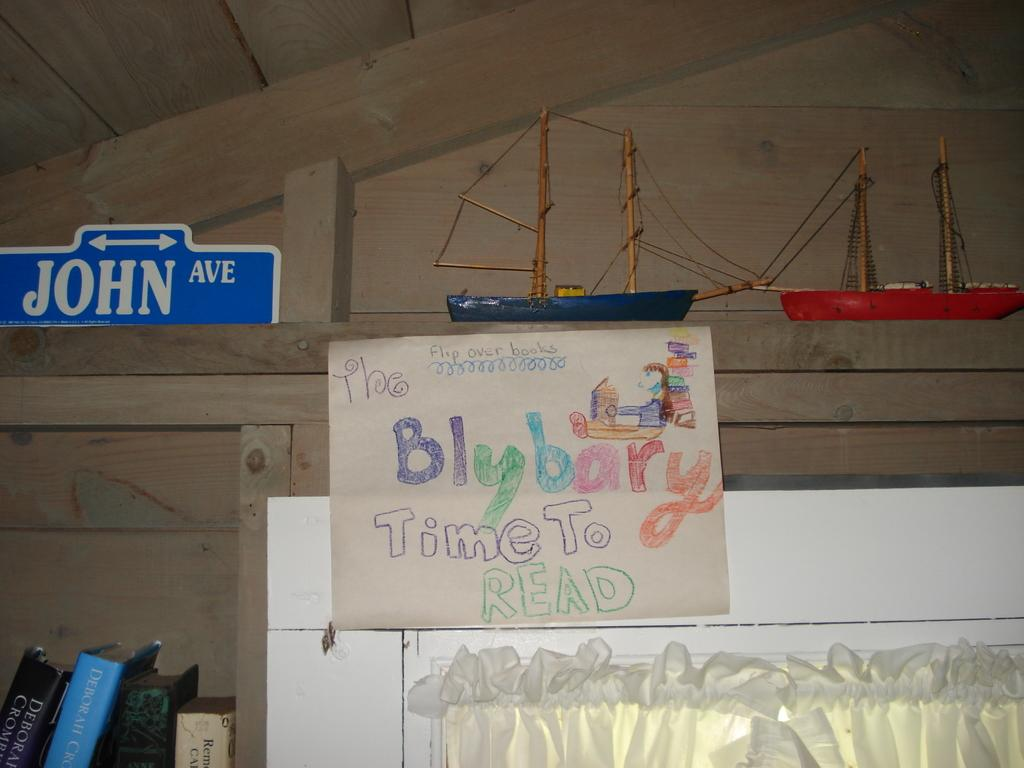<image>
Write a terse but informative summary of the picture. Sign saying "Time To read" hanging on a wall under a model ship. 